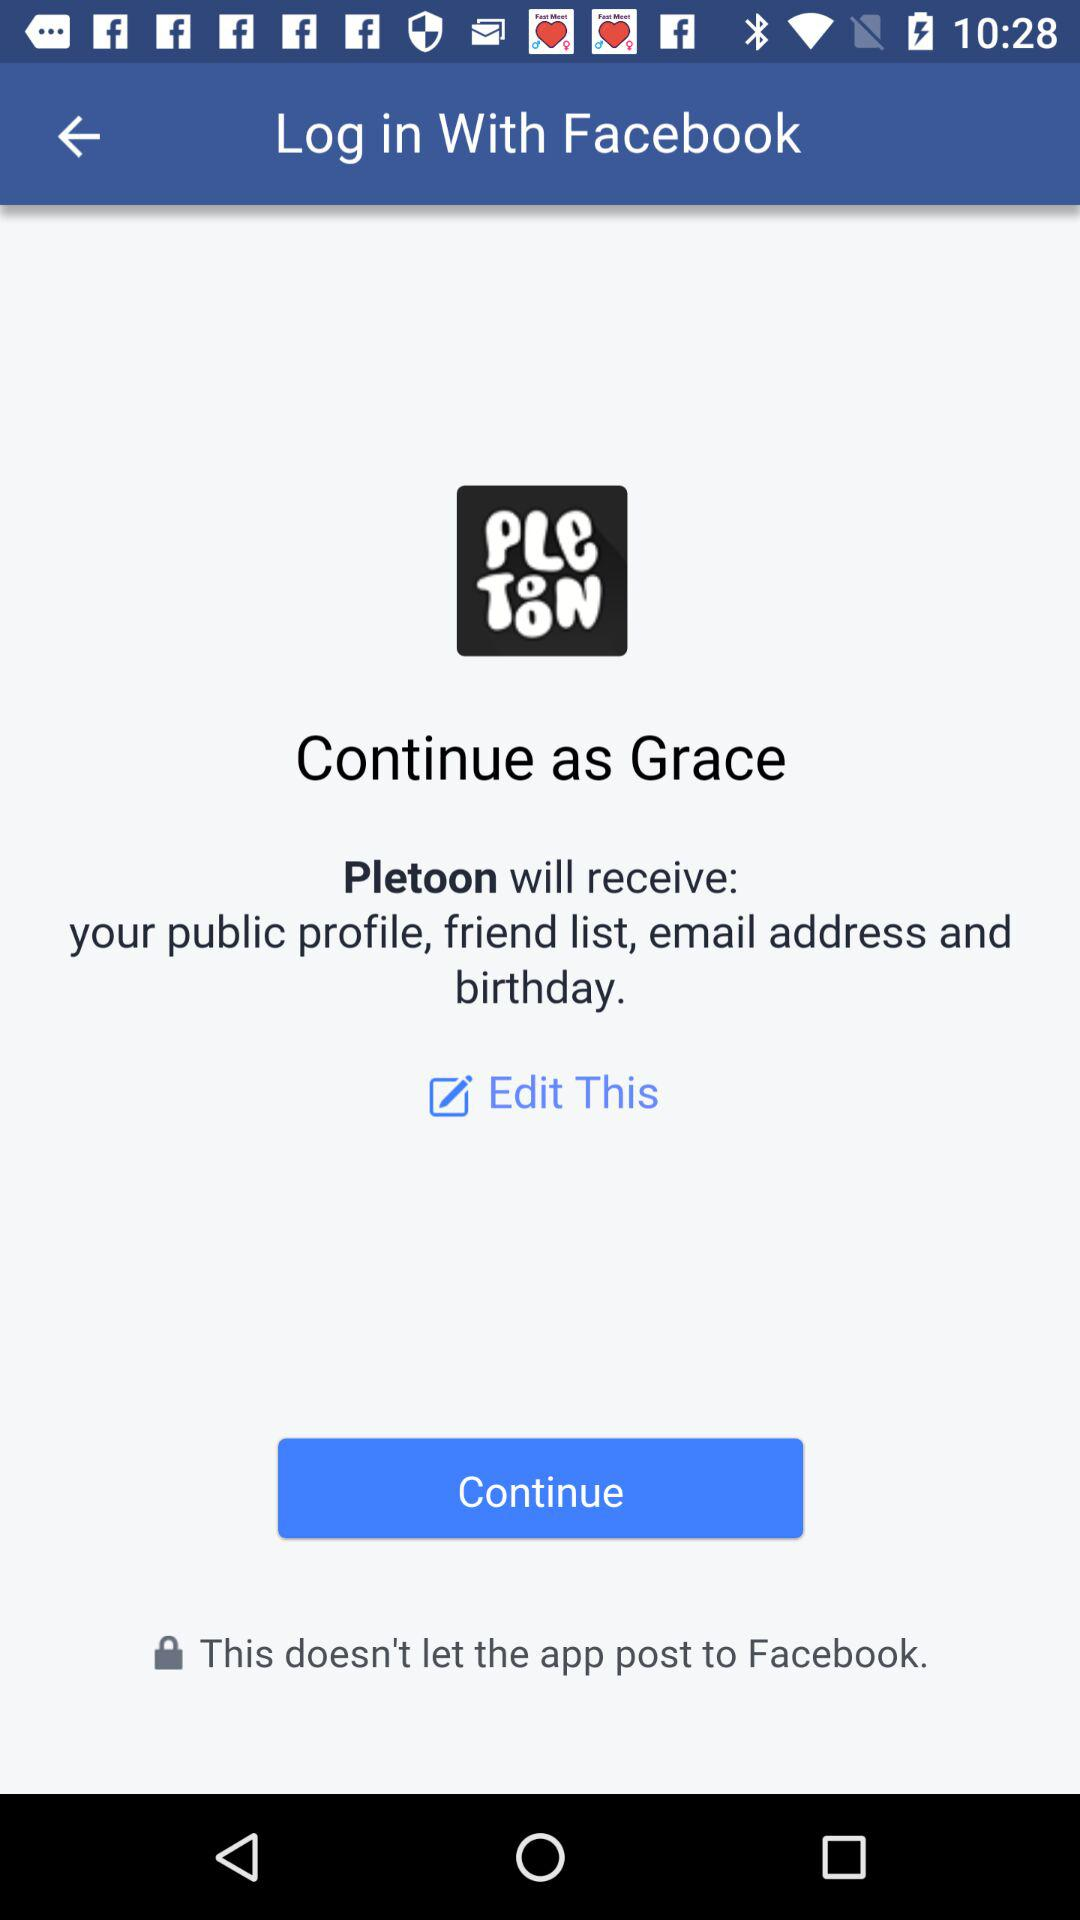What application will receive a public profile, friend list, and email address? The application will receive a public profile, friend list and email address is "Pletoon". 